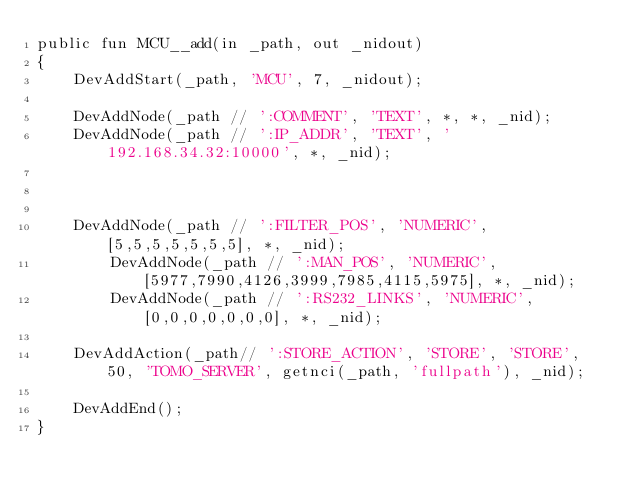<code> <loc_0><loc_0><loc_500><loc_500><_SML_>public fun MCU__add(in _path, out _nidout)
{
	DevAddStart(_path, 'MCU', 7, _nidout);

	DevAddNode(_path // ':COMMENT', 'TEXT', *, *, _nid);
	DevAddNode(_path // ':IP_ADDR', 'TEXT', '192.168.34.32:10000', *, _nid);



	DevAddNode(_path // ':FILTER_POS', 'NUMERIC', [5,5,5,5,5,5,5], *, _nid);
    	DevAddNode(_path // ':MAN_POS', 'NUMERIC', [5977,7990,4126,3999,7985,4115,5975], *, _nid);
    	DevAddNode(_path // ':RS232_LINKS', 'NUMERIC', [0,0,0,0,0,0,0], *, _nid);
	
	DevAddAction(_path// ':STORE_ACTION', 'STORE', 'STORE', 50, 'TOMO_SERVER', getnci(_path, 'fullpath'), _nid);
    
	DevAddEnd();
}
</code> 